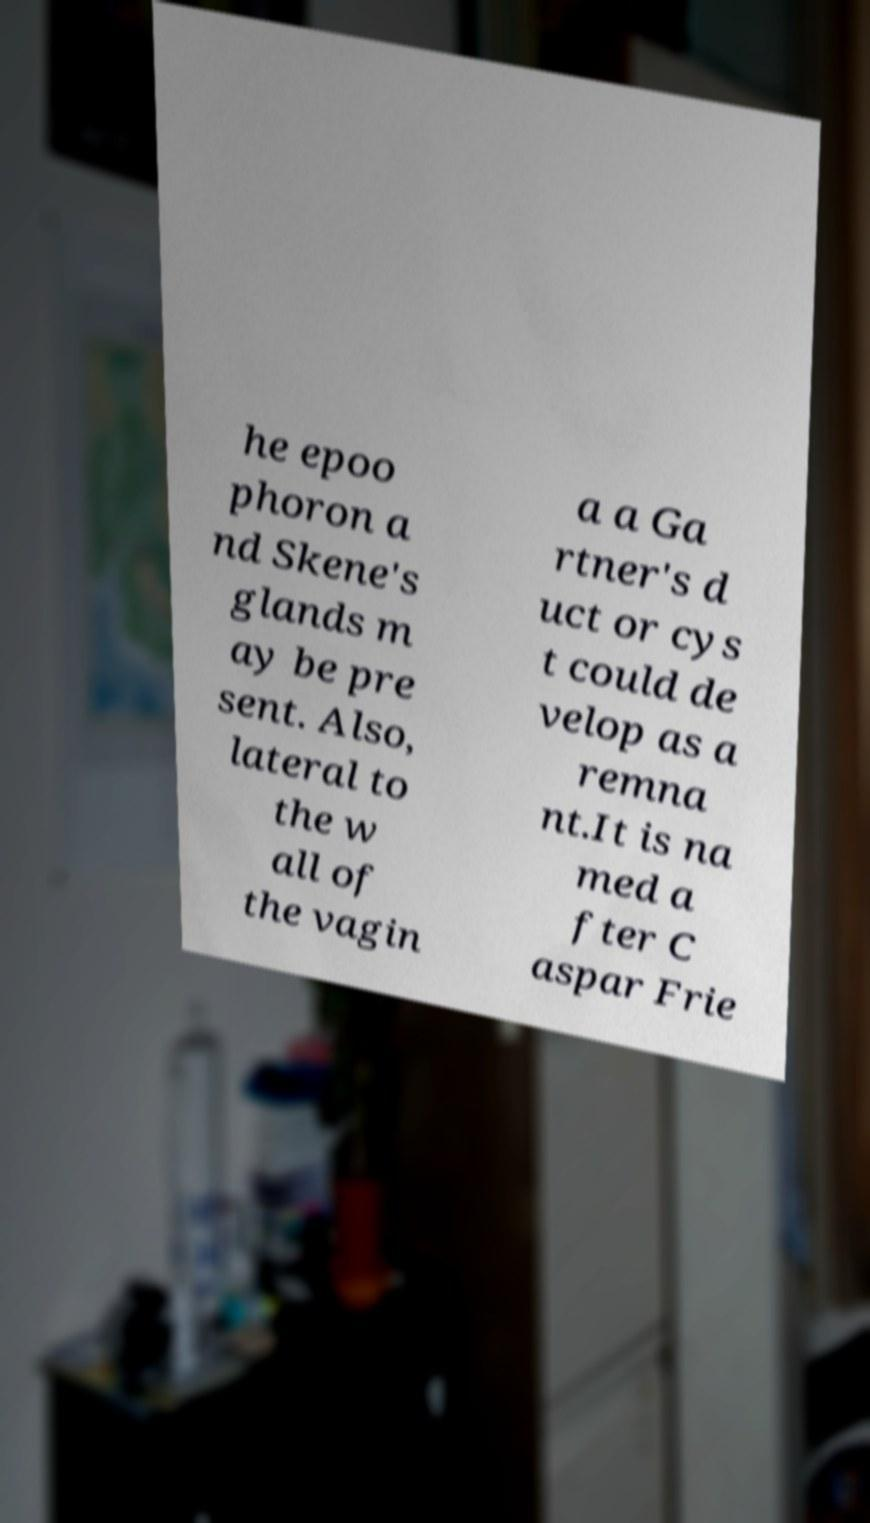What messages or text are displayed in this image? I need them in a readable, typed format. he epoo phoron a nd Skene's glands m ay be pre sent. Also, lateral to the w all of the vagin a a Ga rtner's d uct or cys t could de velop as a remna nt.It is na med a fter C aspar Frie 